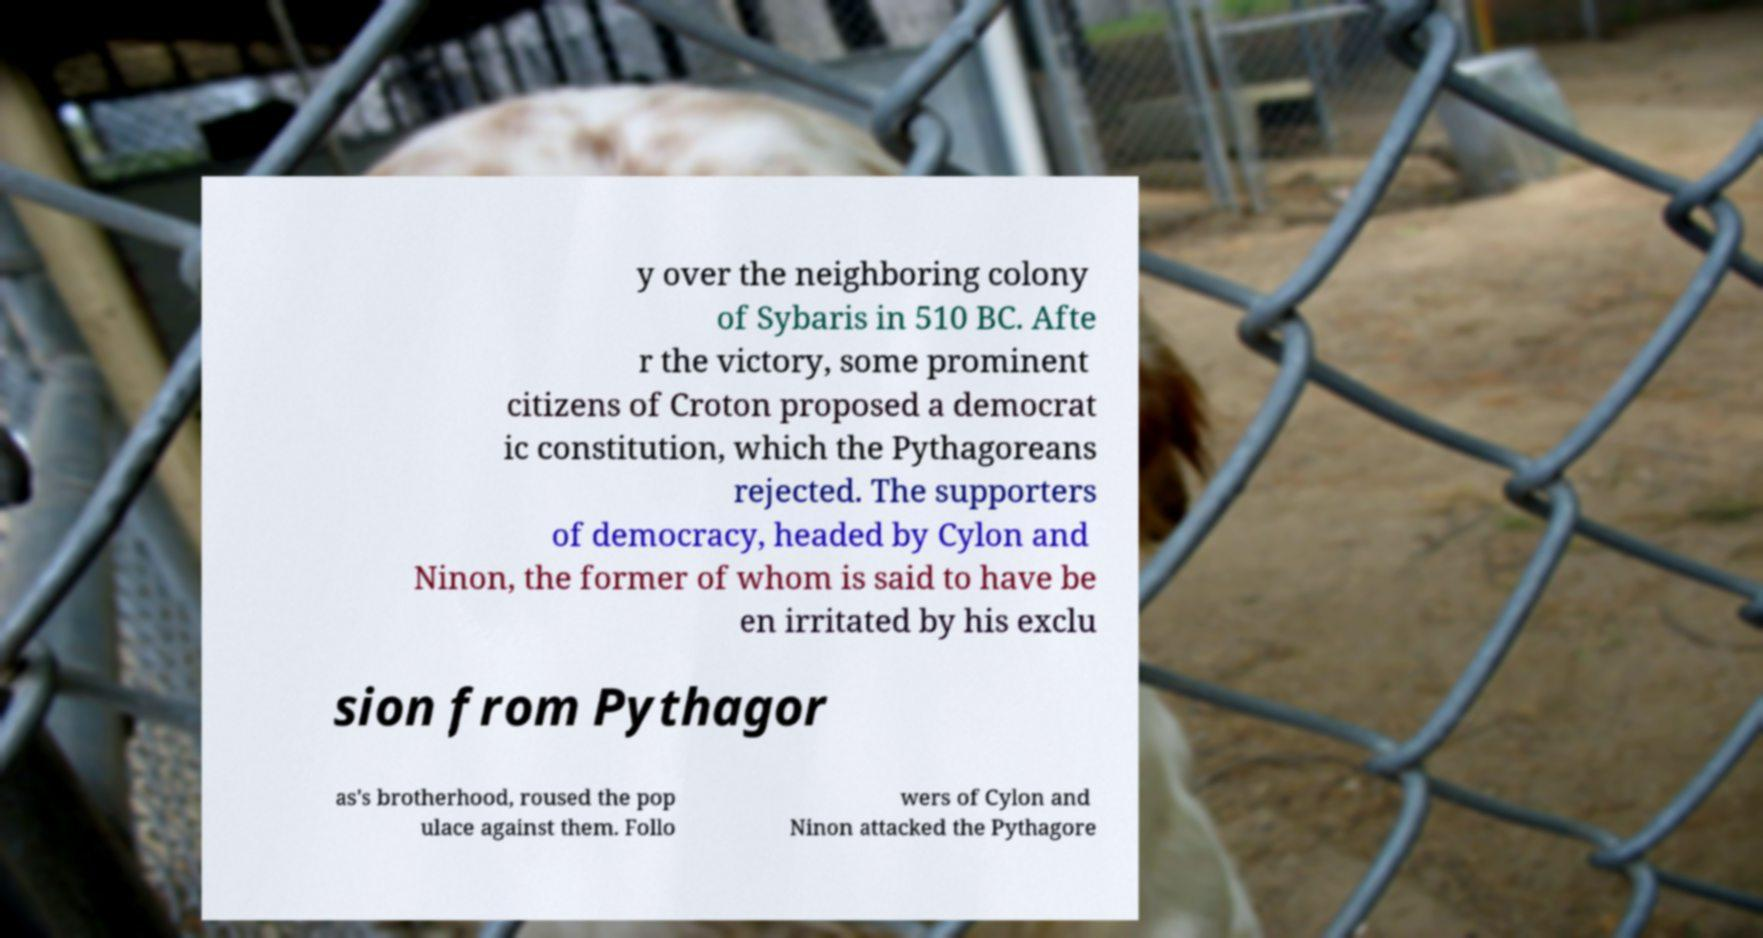Could you extract and type out the text from this image? y over the neighboring colony of Sybaris in 510 BC. Afte r the victory, some prominent citizens of Croton proposed a democrat ic constitution, which the Pythagoreans rejected. The supporters of democracy, headed by Cylon and Ninon, the former of whom is said to have be en irritated by his exclu sion from Pythagor as's brotherhood, roused the pop ulace against them. Follo wers of Cylon and Ninon attacked the Pythagore 